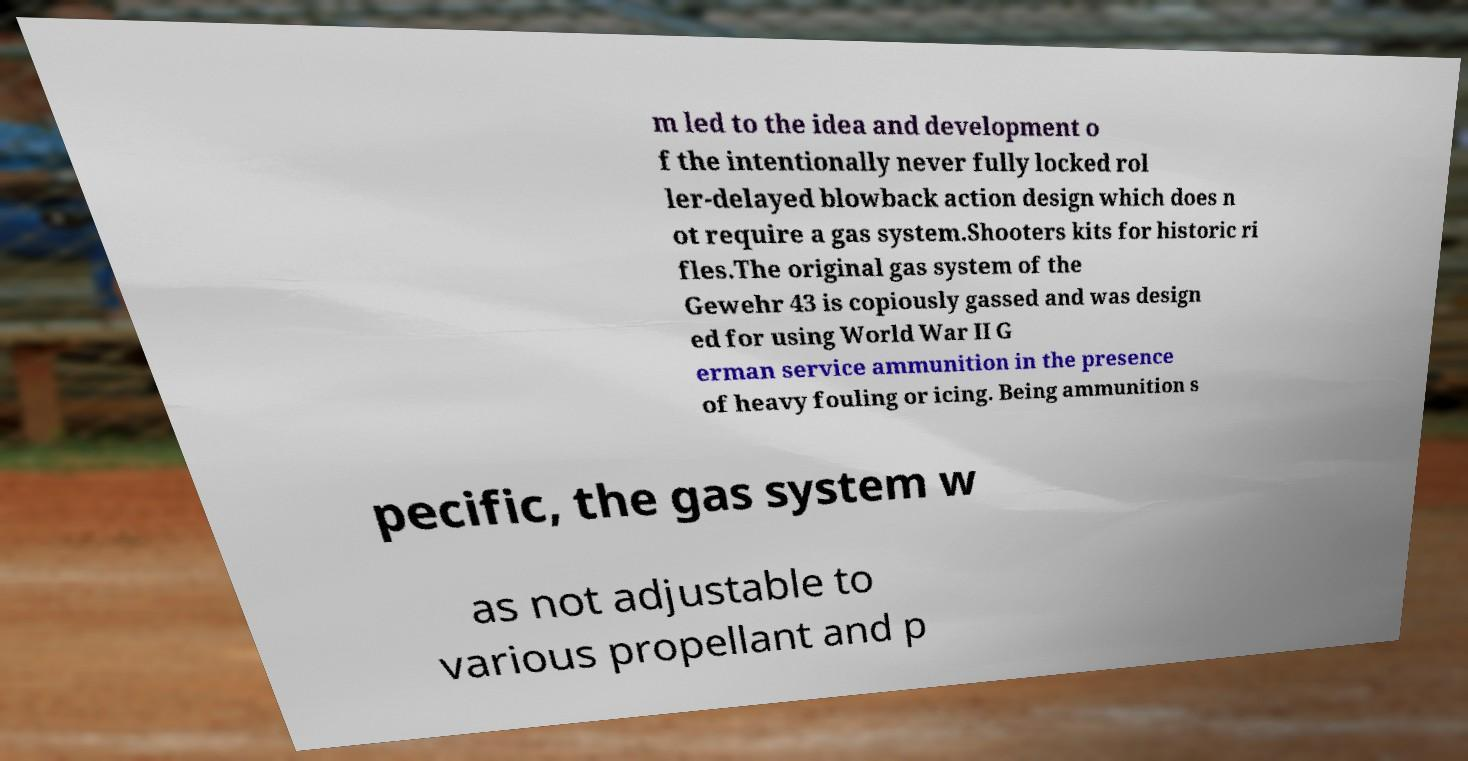I need the written content from this picture converted into text. Can you do that? m led to the idea and development o f the intentionally never fully locked rol ler-delayed blowback action design which does n ot require a gas system.Shooters kits for historic ri fles.The original gas system of the Gewehr 43 is copiously gassed and was design ed for using World War II G erman service ammunition in the presence of heavy fouling or icing. Being ammunition s pecific, the gas system w as not adjustable to various propellant and p 